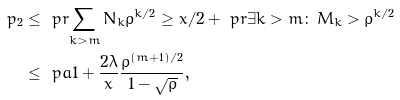<formula> <loc_0><loc_0><loc_500><loc_500>p _ { 2 } & \leq \ p r { \sum _ { k > m } N _ { k } \rho ^ { k / 2 } \geq x / 2 } + \ p r { \exists k > m \colon \, M _ { k } > \rho ^ { k / 2 } } \\ & \leq \ p a { 1 + \frac { 2 \lambda } x } \frac { \rho ^ { ( m + 1 ) / 2 } } { 1 - \sqrt { \rho } } ,</formula> 